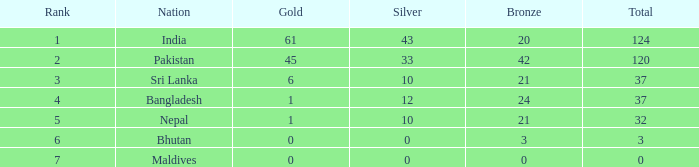What is the amount of silver with a ranking of 7? 1.0. 